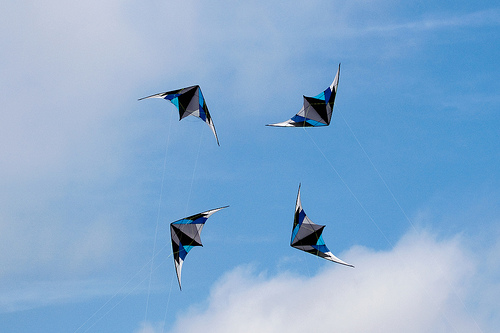<image>
Can you confirm if the kite is under the sky? Yes. The kite is positioned underneath the sky, with the sky above it in the vertical space. Is the kite on the sky? No. The kite is not positioned on the sky. They may be near each other, but the kite is not supported by or resting on top of the sky. 